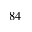Convert formula to latex. <formula><loc_0><loc_0><loc_500><loc_500>^ { 8 4 }</formula> 